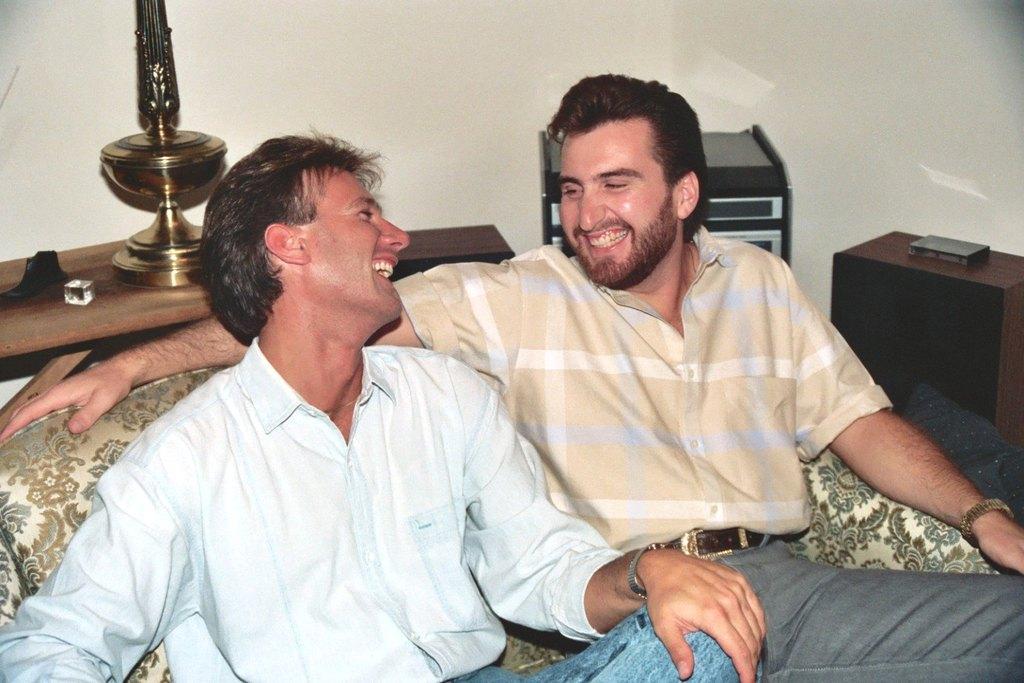Can you describe this image briefly? In this picture we can see two men sitting on sofa and they are smiling and beside to them we have table with dice on it and in the background we can see wall. 